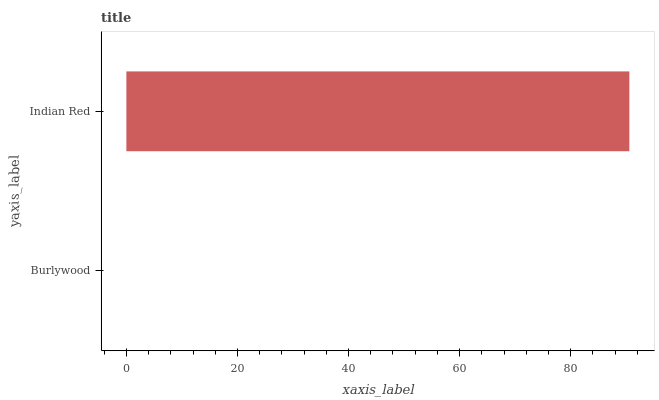Is Burlywood the minimum?
Answer yes or no. Yes. Is Indian Red the maximum?
Answer yes or no. Yes. Is Indian Red the minimum?
Answer yes or no. No. Is Indian Red greater than Burlywood?
Answer yes or no. Yes. Is Burlywood less than Indian Red?
Answer yes or no. Yes. Is Burlywood greater than Indian Red?
Answer yes or no. No. Is Indian Red less than Burlywood?
Answer yes or no. No. Is Indian Red the high median?
Answer yes or no. Yes. Is Burlywood the low median?
Answer yes or no. Yes. Is Burlywood the high median?
Answer yes or no. No. Is Indian Red the low median?
Answer yes or no. No. 